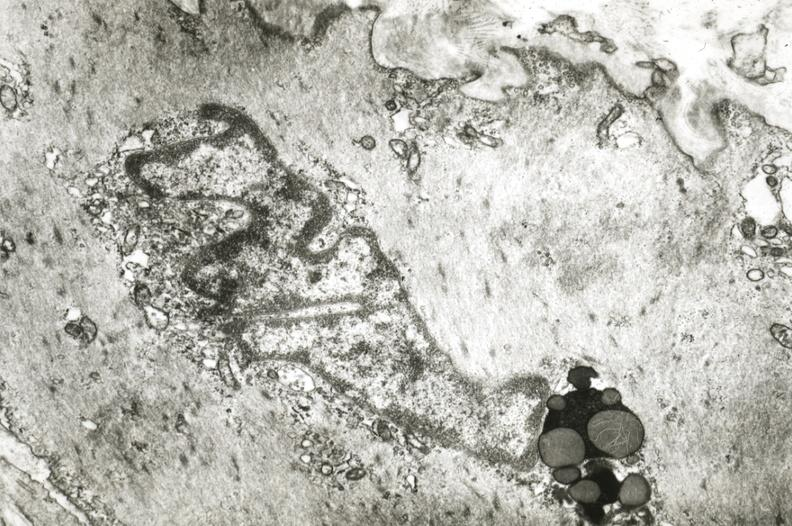s lymphangiomatosis present?
Answer the question using a single word or phrase. No 